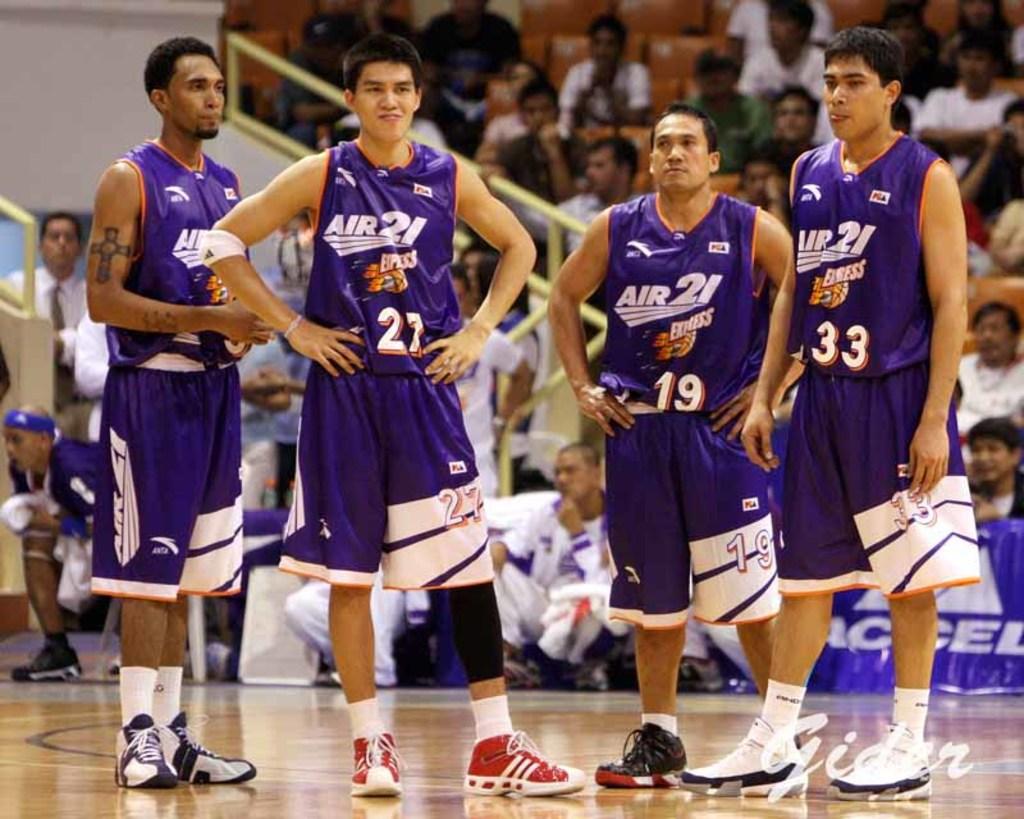What number is the shortest player of the four?
Provide a succinct answer. 19. What team do they play for?
Offer a very short reply. Air 21. 